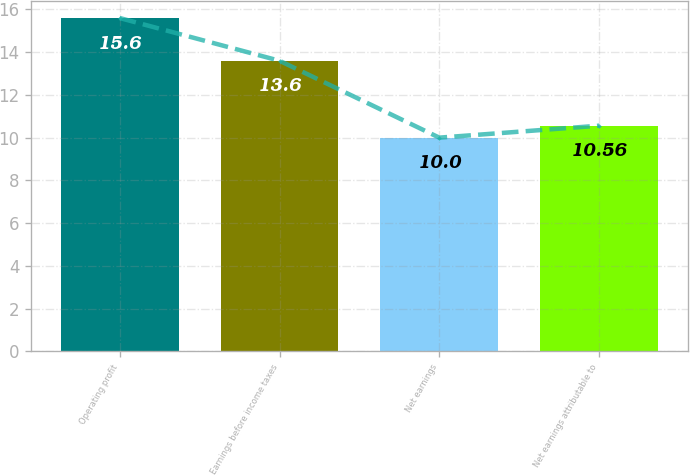Convert chart. <chart><loc_0><loc_0><loc_500><loc_500><bar_chart><fcel>Operating profit<fcel>Earnings before income taxes<fcel>Net earnings<fcel>Net earnings attributable to<nl><fcel>15.6<fcel>13.6<fcel>10<fcel>10.56<nl></chart> 